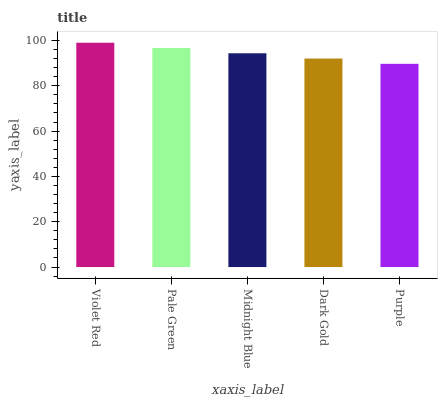Is Purple the minimum?
Answer yes or no. Yes. Is Violet Red the maximum?
Answer yes or no. Yes. Is Pale Green the minimum?
Answer yes or no. No. Is Pale Green the maximum?
Answer yes or no. No. Is Violet Red greater than Pale Green?
Answer yes or no. Yes. Is Pale Green less than Violet Red?
Answer yes or no. Yes. Is Pale Green greater than Violet Red?
Answer yes or no. No. Is Violet Red less than Pale Green?
Answer yes or no. No. Is Midnight Blue the high median?
Answer yes or no. Yes. Is Midnight Blue the low median?
Answer yes or no. Yes. Is Dark Gold the high median?
Answer yes or no. No. Is Purple the low median?
Answer yes or no. No. 